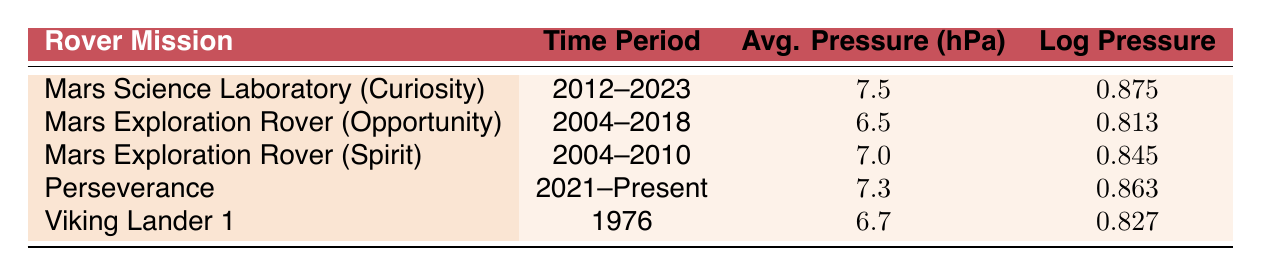What is the average pressure recorded during the Mars Science Laboratory (Curiosity) mission? The table shows that the average pressure for the Mars Science Laboratory (Curiosity) mission is listed under the corresponding row. According to the data, this value is 7.5 hPa.
Answer: 7.5 hPa Which mission had the lowest average atmospheric pressure? By inspecting the average pressure column, the Mars Exploration Rover (Opportunity) has the lowest value of 6.5 hPa, as it is the smallest number when compared to all other missions listed.
Answer: Mars Exploration Rover (Opportunity) Is the average pressure during the Perseverance mission higher than 7.0 hPa? The average pressure for the Perseverance mission is 7.3 hPa, which is indeed greater than 7.0 hPa. This can be confirmed by comparing the specific average pressure value listed for Perseverance to the threshold of 7.0 hPa.
Answer: Yes What is the difference in average pressure between Mars Exploration Rover (Opportunity) and Viking Lander 1? The average pressure for Mars Exploration Rover (Opportunity) is 6.5 hPa and for Viking Lander 1 it is 6.7 hPa. The difference can be calculated by subtracting the value for Opportunity from the value for Viking Lander: 6.7 - 6.5 = 0.2 hPa.
Answer: 0.2 hPa If we sum up all the average pressures recorded for the rover missions, what is the total? To find the total average pressure, we must add the average pressures from all missions: 7.5 + 6.5 + 7.0 + 7.3 + 6.7 = 35.0 hPa. This is done by simply performing the addition of the values found in the table.
Answer: 35.0 hPa Which mission has an average pressure greater than the average pressure of Viking Lander 1? Viking Lander 1 has an average pressure of 6.7 hPa. By examining the table, we see that Mars Science Laboratory (Curiosity), Mars Exploration Rover (Spirit), and Perseverance have average pressures greater than 6.7 hPa, as their values are 7.5 hPa, 7.0 hPa, and 7.3 hPa respectively.
Answer: Mars Science Laboratory (Curiosity), Mars Exploration Rover (Spirit), Perseverance Determine the mission with the highest recorded log pressure value. The log pressure values are found in the fourth column of the table. By scanning these values, we see that the highest log pressure is 0.875, associated with the Mars Science Laboratory (Curiosity) mission.
Answer: Mars Science Laboratory (Curiosity) 